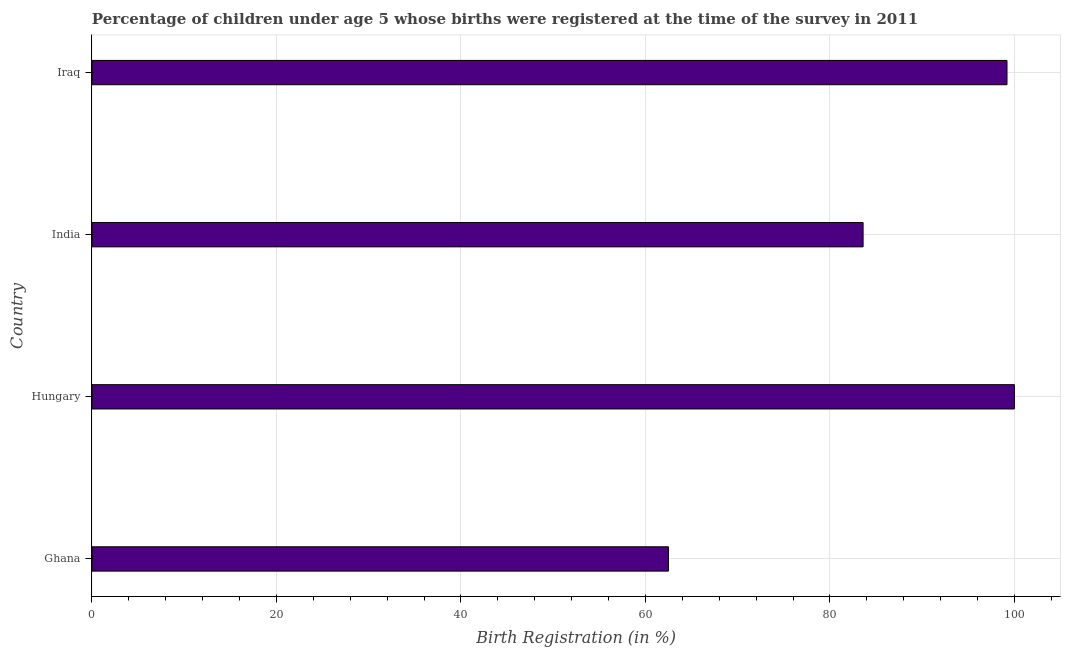Does the graph contain grids?
Offer a terse response. Yes. What is the title of the graph?
Give a very brief answer. Percentage of children under age 5 whose births were registered at the time of the survey in 2011. What is the label or title of the X-axis?
Your answer should be very brief. Birth Registration (in %). Across all countries, what is the minimum birth registration?
Make the answer very short. 62.5. In which country was the birth registration maximum?
Your answer should be very brief. Hungary. In which country was the birth registration minimum?
Provide a succinct answer. Ghana. What is the sum of the birth registration?
Make the answer very short. 345.3. What is the difference between the birth registration in Ghana and India?
Your answer should be very brief. -21.1. What is the average birth registration per country?
Keep it short and to the point. 86.33. What is the median birth registration?
Make the answer very short. 91.4. In how many countries, is the birth registration greater than 36 %?
Provide a short and direct response. 4. What is the ratio of the birth registration in Hungary to that in India?
Give a very brief answer. 1.2. What is the difference between the highest and the second highest birth registration?
Give a very brief answer. 0.8. What is the difference between the highest and the lowest birth registration?
Offer a terse response. 37.5. How many bars are there?
Offer a terse response. 4. Are all the bars in the graph horizontal?
Your answer should be compact. Yes. What is the Birth Registration (in %) of Ghana?
Give a very brief answer. 62.5. What is the Birth Registration (in %) in India?
Make the answer very short. 83.6. What is the Birth Registration (in %) in Iraq?
Provide a succinct answer. 99.2. What is the difference between the Birth Registration (in %) in Ghana and Hungary?
Your answer should be compact. -37.5. What is the difference between the Birth Registration (in %) in Ghana and India?
Provide a short and direct response. -21.1. What is the difference between the Birth Registration (in %) in Ghana and Iraq?
Make the answer very short. -36.7. What is the difference between the Birth Registration (in %) in Hungary and India?
Your answer should be very brief. 16.4. What is the difference between the Birth Registration (in %) in India and Iraq?
Provide a short and direct response. -15.6. What is the ratio of the Birth Registration (in %) in Ghana to that in India?
Ensure brevity in your answer.  0.75. What is the ratio of the Birth Registration (in %) in Ghana to that in Iraq?
Your answer should be compact. 0.63. What is the ratio of the Birth Registration (in %) in Hungary to that in India?
Give a very brief answer. 1.2. What is the ratio of the Birth Registration (in %) in India to that in Iraq?
Ensure brevity in your answer.  0.84. 